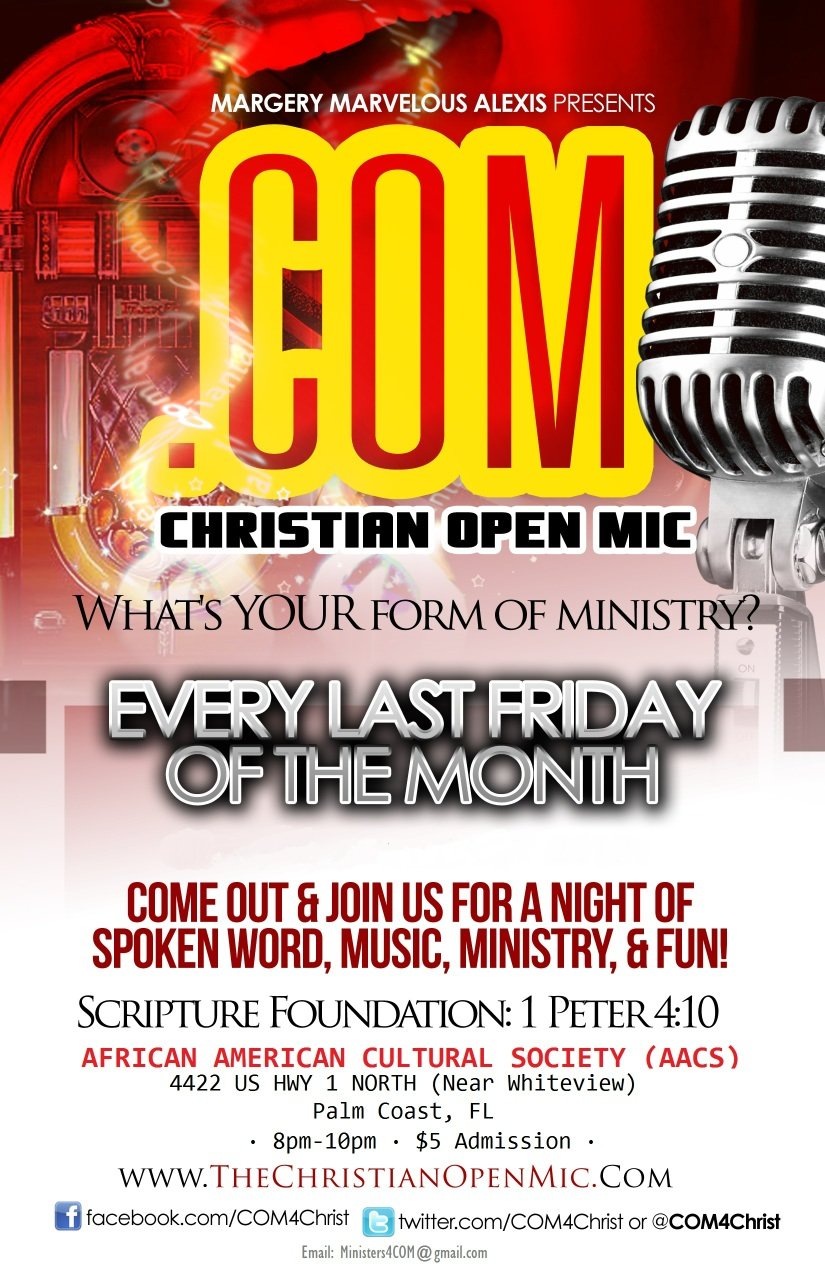What kind of activities can one expect at the Christian Open Mic event? The Christian Open Mic event typically includes activities such as spoken word performances, live music, ministry sessions, and interactive fun activities. These events provide a platform for artists, ministers, and community members to share their talents and messages in an engaging environment. 